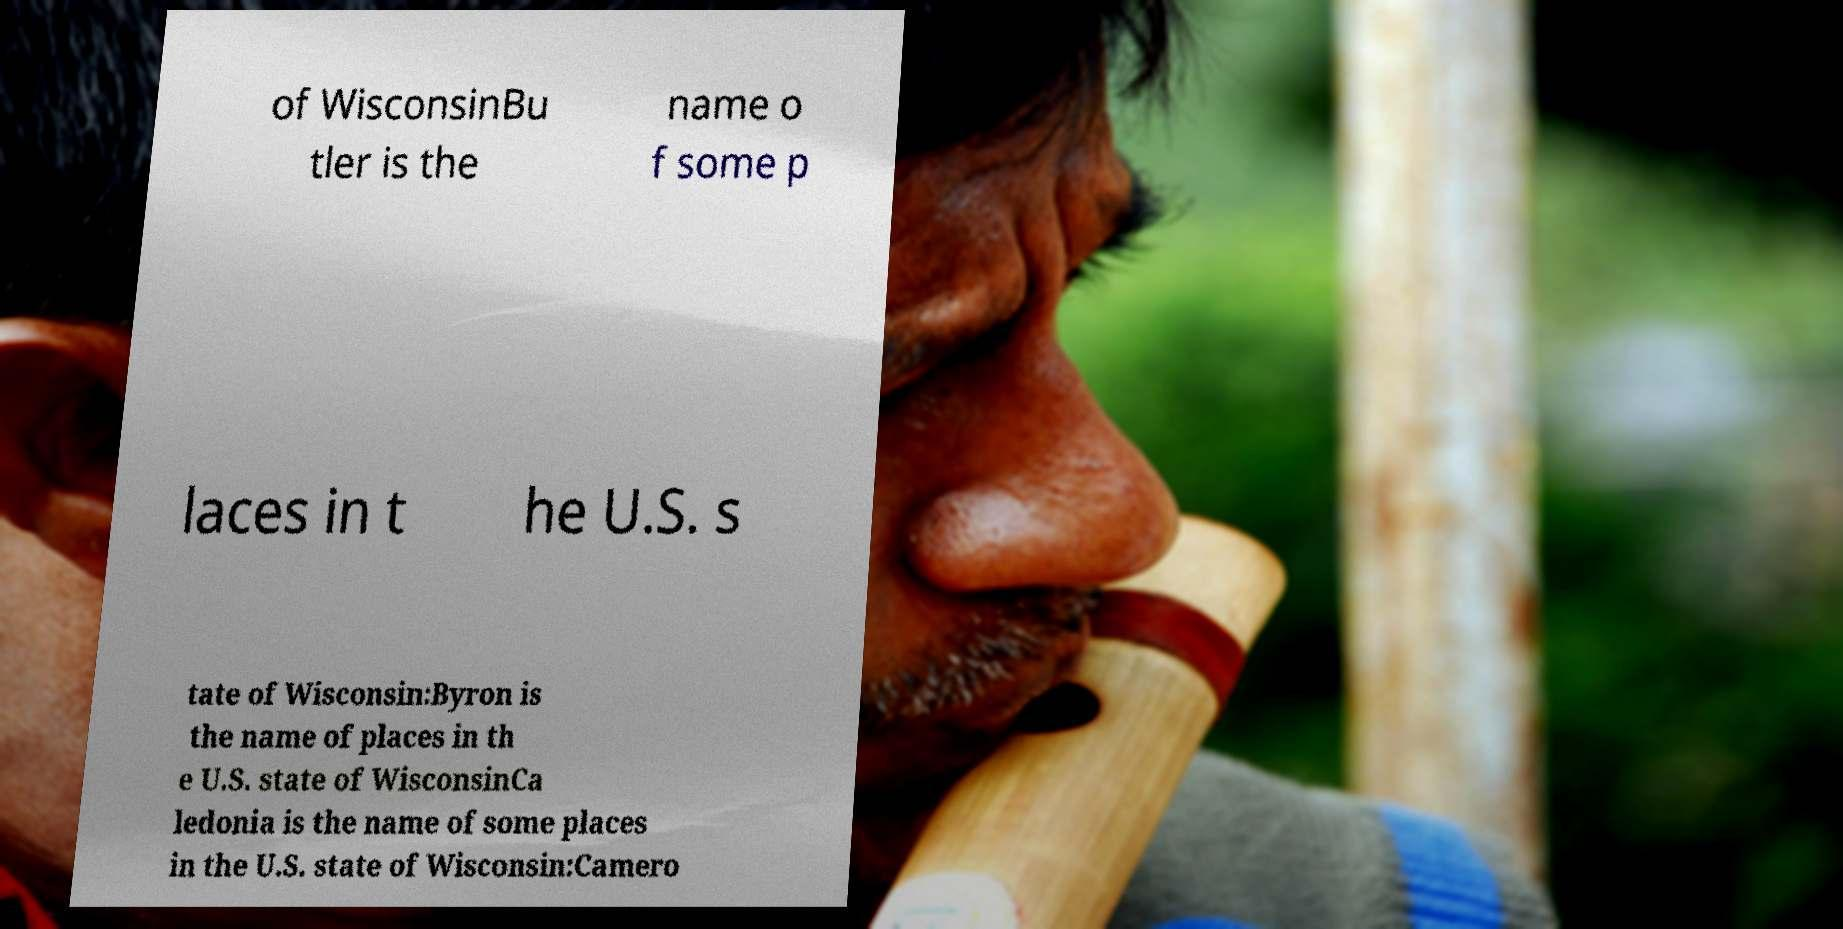For documentation purposes, I need the text within this image transcribed. Could you provide that? of WisconsinBu tler is the name o f some p laces in t he U.S. s tate of Wisconsin:Byron is the name of places in th e U.S. state of WisconsinCa ledonia is the name of some places in the U.S. state of Wisconsin:Camero 